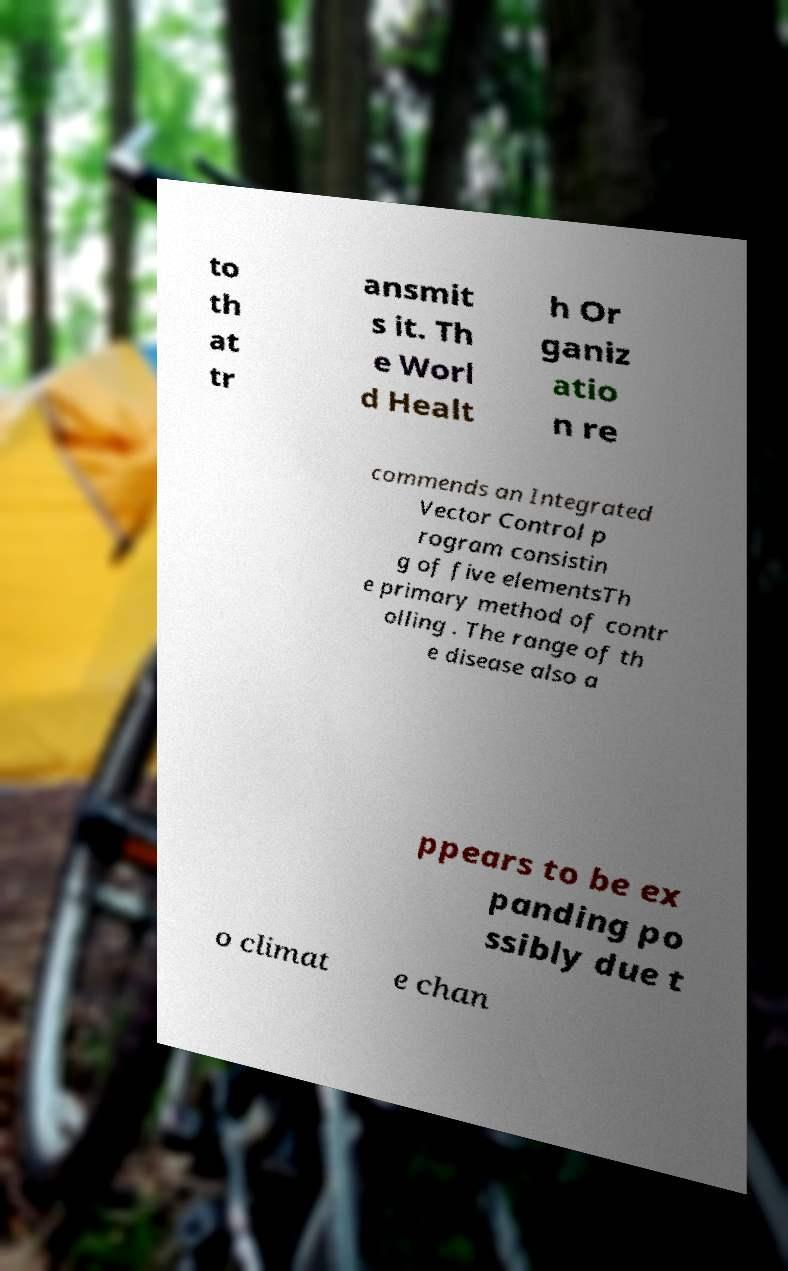Please identify and transcribe the text found in this image. to th at tr ansmit s it. Th e Worl d Healt h Or ganiz atio n re commends an Integrated Vector Control p rogram consistin g of five elementsTh e primary method of contr olling . The range of th e disease also a ppears to be ex panding po ssibly due t o climat e chan 